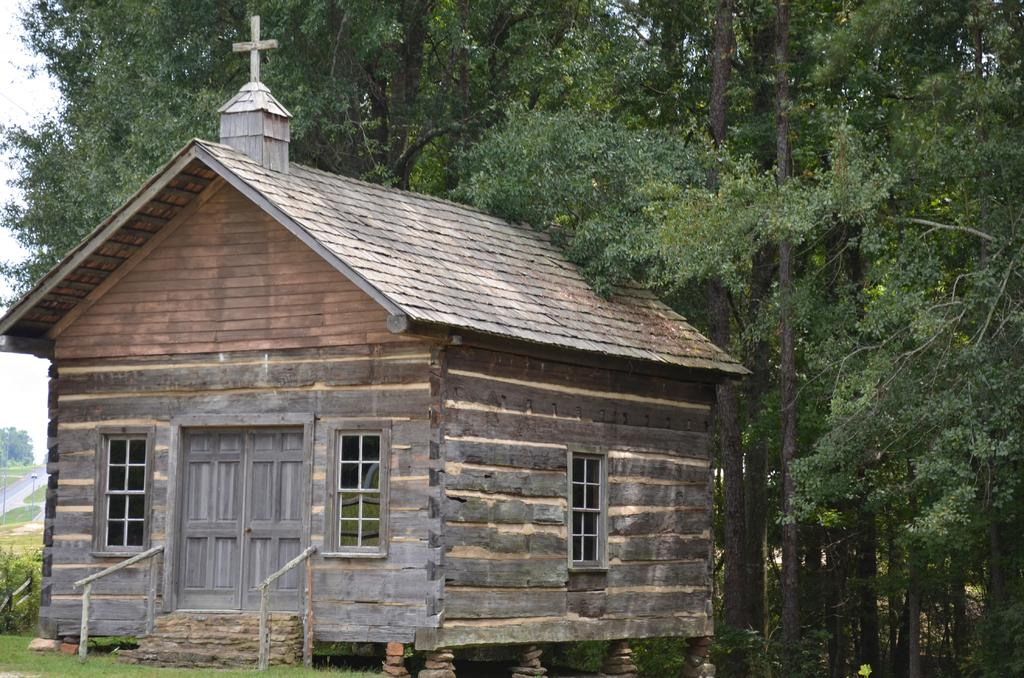What type of structure is in the picture? There is a house in the picture. What features can be seen on the house? The house has windows and doors. What can be seen in the background of the picture? There are trees, plants, grass, and the sky visible in the background of the picture. What type of books are being exchanged during the birthday party in the image? There is no birthday party or exchange of books depicted in the image; it features a house with windows and doors, and a background with trees, plants, grass, and the sky. 